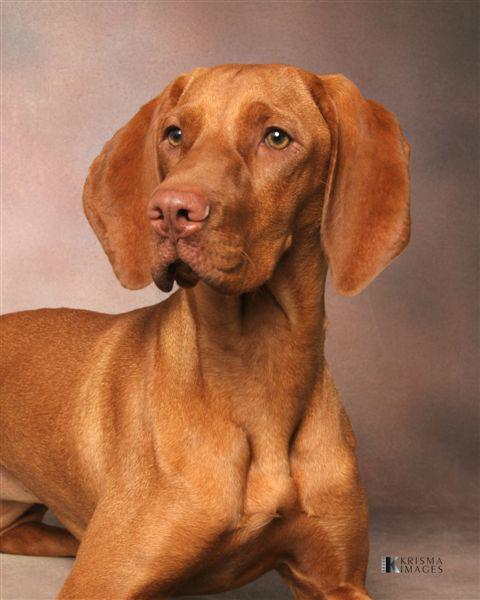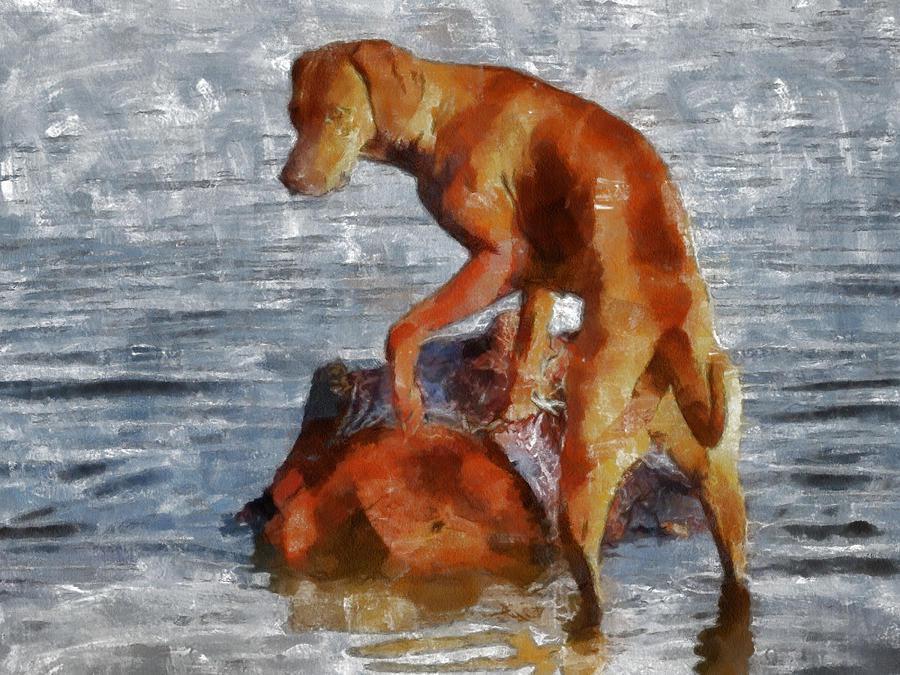The first image is the image on the left, the second image is the image on the right. For the images shown, is this caption "One image shows a red-orange hound gazing somewhat forward, and the other image includes a left-facing red-orange hound with the front paw closest to the camera raised." true? Answer yes or no. Yes. 